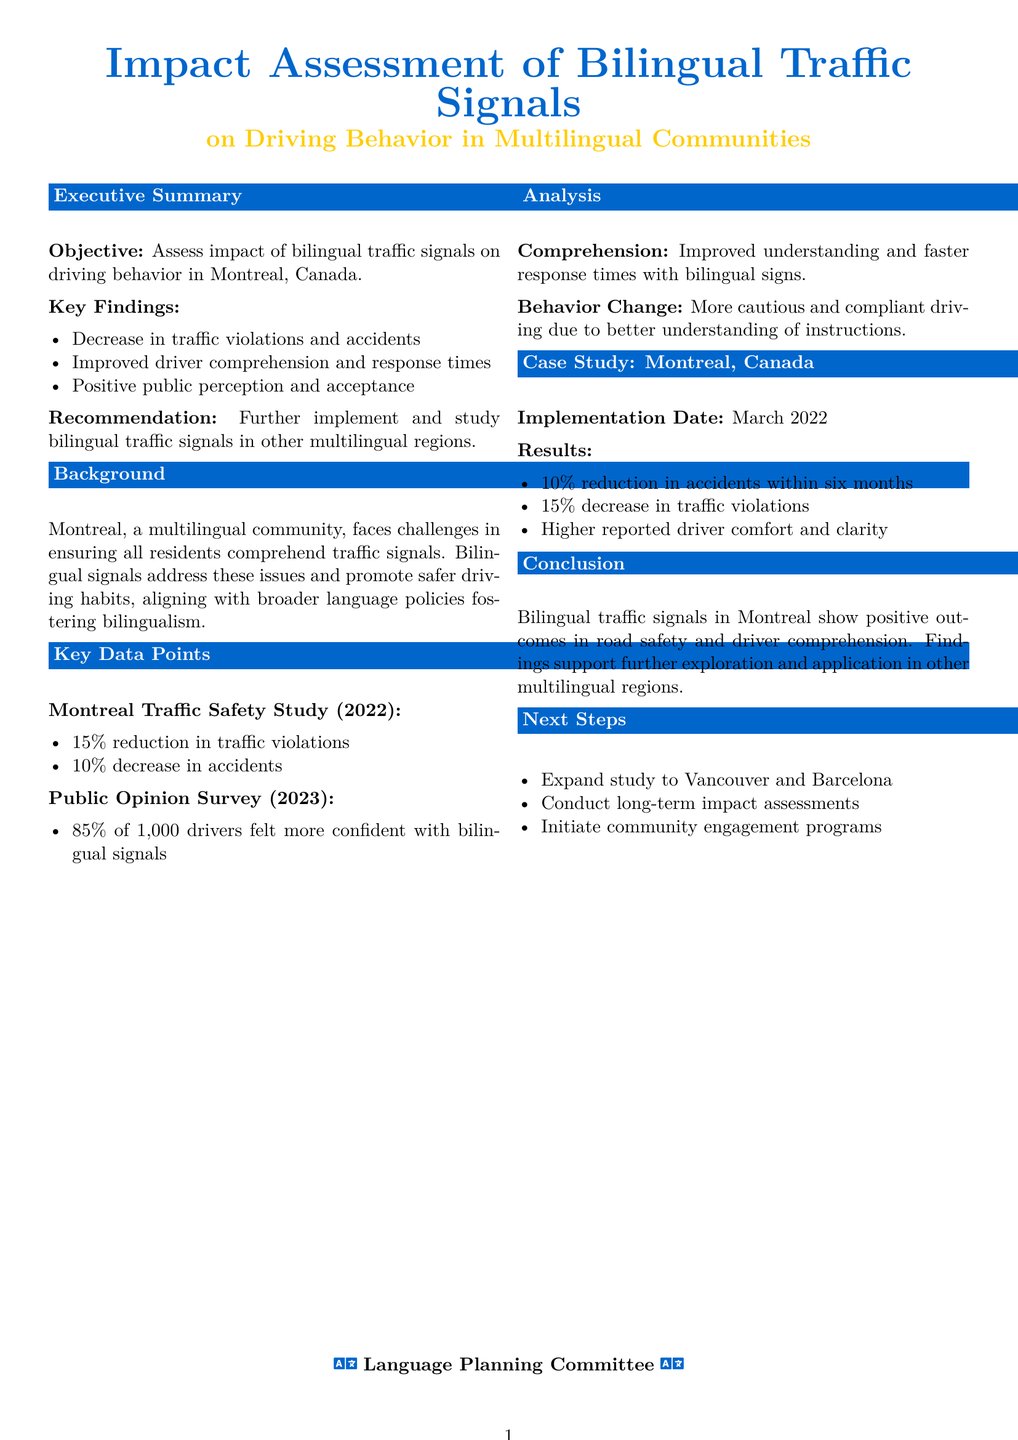What is the objective of the report? The objective is to assess the impact of bilingual traffic signals on driving behavior in Montreal, Canada.
Answer: Assess impact of bilingual traffic signals on driving behavior in Montreal, Canada What percentage reduction in traffic violations was observed? The document states that there was a 15% reduction in traffic violations based on the Montreal Traffic Safety Study.
Answer: 15% What is the implementation date of bilingual traffic signals in Montreal? The implementation date of bilingual traffic signals in Montreal was March 2022.
Answer: March 2022 How many drivers were surveyed in the Public Opinion Survey? The document indicates that 1,000 drivers were surveyed in the Public Opinion Survey.
Answer: 1,000 What is the recommendation made in the report? The report recommends further implementation and study of bilingual traffic signals in other multilingual regions.
Answer: Further implement and study bilingual traffic signals in other multilingual regions What is the observed decrease in accidents within six months? The document notes a 10% reduction in accidents within six months of implementation.
Answer: 10% What was the public perception of bilingual traffic signals? According to the report, public perception was positive, with 85% of drivers feeling more confident with bilingual signals.
Answer: Positive public perception and acceptance What is one of the next steps proposed in the report? One of the next steps proposed is to expand the study to Vancouver and Barcelona.
Answer: Expand study to Vancouver and Barcelona 